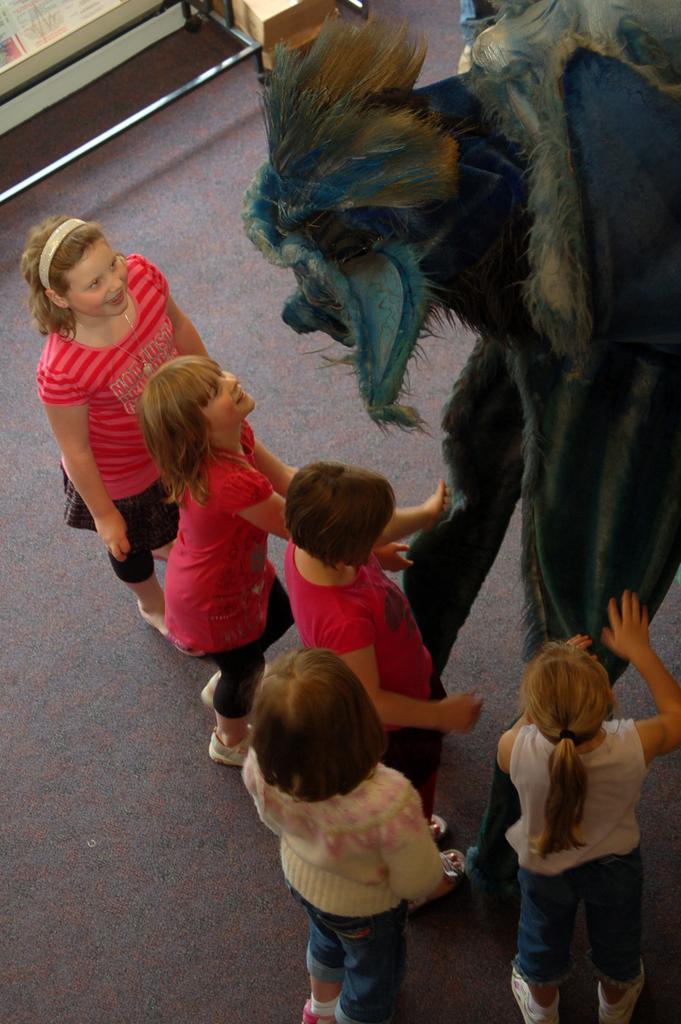Could you give a brief overview of what you see in this image? In this image, we can see few girls are standing on the floor. Here we can see some decorative object. Top of the image, we can see few objects. Here we can see few girls are smiling. 